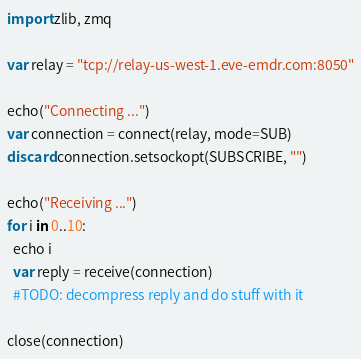Convert code to text. <code><loc_0><loc_0><loc_500><loc_500><_Nim_>import zlib, zmq

var relay = "tcp://relay-us-west-1.eve-emdr.com:8050"

echo("Connecting ...")
var connection = connect(relay, mode=SUB)
discard connection.setsockopt(SUBSCRIBE, "")

echo("Receiving ...")
for i in 0..10:
  echo i
  var reply = receive(connection)
  #TODO: decompress reply and do stuff with it

close(connection)
</code> 